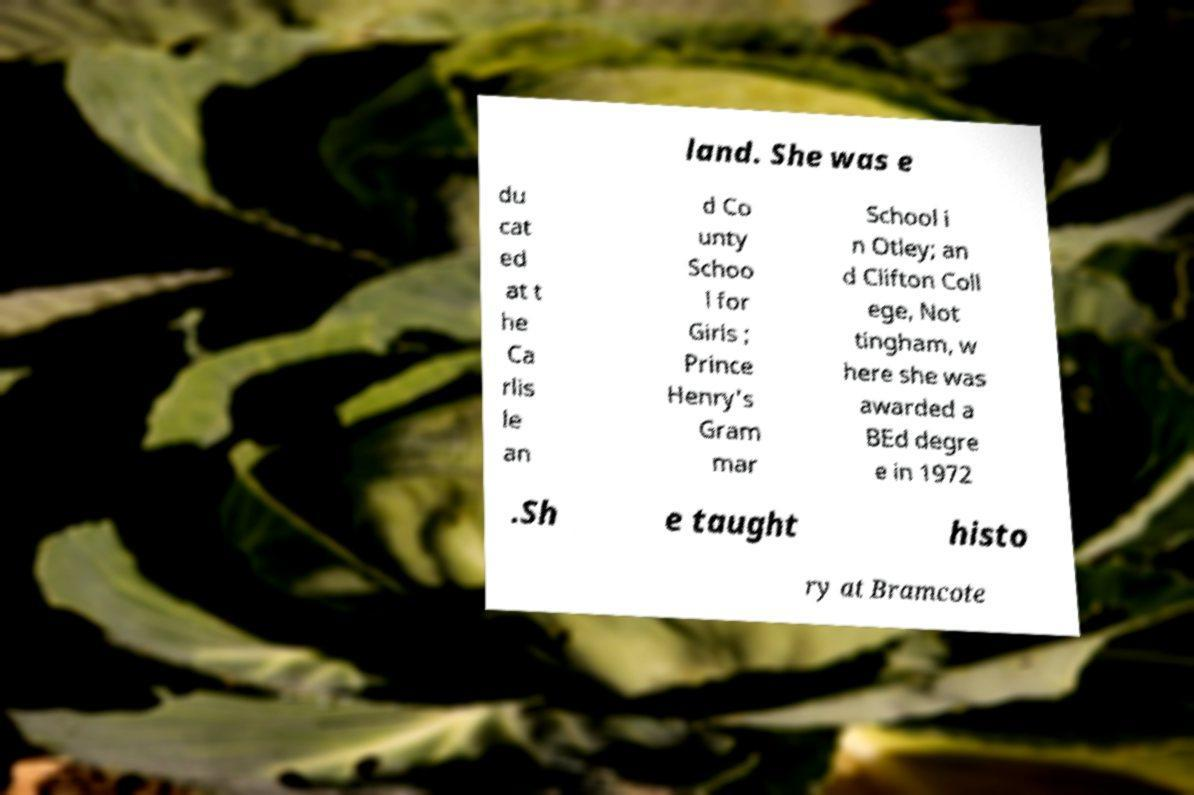For documentation purposes, I need the text within this image transcribed. Could you provide that? land. She was e du cat ed at t he Ca rlis le an d Co unty Schoo l for Girls ; Prince Henry's Gram mar School i n Otley; an d Clifton Coll ege, Not tingham, w here she was awarded a BEd degre e in 1972 .Sh e taught histo ry at Bramcote 